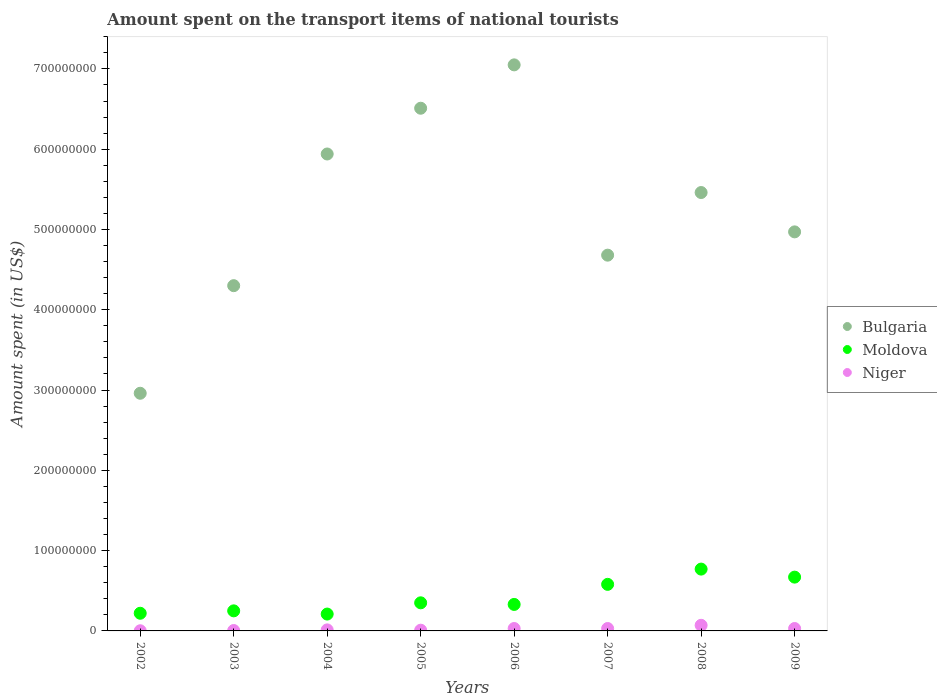Is the number of dotlines equal to the number of legend labels?
Provide a succinct answer. Yes. What is the amount spent on the transport items of national tourists in Bulgaria in 2007?
Keep it short and to the point. 4.68e+08. Across all years, what is the maximum amount spent on the transport items of national tourists in Bulgaria?
Provide a short and direct response. 7.05e+08. Across all years, what is the minimum amount spent on the transport items of national tourists in Bulgaria?
Give a very brief answer. 2.96e+08. What is the total amount spent on the transport items of national tourists in Moldova in the graph?
Give a very brief answer. 3.38e+08. What is the difference between the amount spent on the transport items of national tourists in Moldova in 2002 and that in 2003?
Keep it short and to the point. -3.00e+06. What is the difference between the amount spent on the transport items of national tourists in Moldova in 2004 and the amount spent on the transport items of national tourists in Niger in 2007?
Ensure brevity in your answer.  1.80e+07. What is the average amount spent on the transport items of national tourists in Niger per year?
Offer a very short reply. 2.36e+06. In the year 2005, what is the difference between the amount spent on the transport items of national tourists in Niger and amount spent on the transport items of national tourists in Moldova?
Ensure brevity in your answer.  -3.41e+07. Is the amount spent on the transport items of national tourists in Moldova in 2003 less than that in 2008?
Your answer should be compact. Yes. Is the difference between the amount spent on the transport items of national tourists in Niger in 2006 and 2009 greater than the difference between the amount spent on the transport items of national tourists in Moldova in 2006 and 2009?
Your response must be concise. Yes. What is the difference between the highest and the second highest amount spent on the transport items of national tourists in Niger?
Your answer should be compact. 4.00e+06. What is the difference between the highest and the lowest amount spent on the transport items of national tourists in Moldova?
Your answer should be compact. 5.60e+07. Is the sum of the amount spent on the transport items of national tourists in Bulgaria in 2006 and 2007 greater than the maximum amount spent on the transport items of national tourists in Moldova across all years?
Ensure brevity in your answer.  Yes. Is it the case that in every year, the sum of the amount spent on the transport items of national tourists in Bulgaria and amount spent on the transport items of national tourists in Niger  is greater than the amount spent on the transport items of national tourists in Moldova?
Your answer should be compact. Yes. Does the amount spent on the transport items of national tourists in Bulgaria monotonically increase over the years?
Provide a short and direct response. No. Is the amount spent on the transport items of national tourists in Moldova strictly greater than the amount spent on the transport items of national tourists in Niger over the years?
Make the answer very short. Yes. How many dotlines are there?
Ensure brevity in your answer.  3. Does the graph contain grids?
Offer a very short reply. No. What is the title of the graph?
Your answer should be very brief. Amount spent on the transport items of national tourists. What is the label or title of the Y-axis?
Offer a very short reply. Amount spent (in US$). What is the Amount spent (in US$) of Bulgaria in 2002?
Provide a short and direct response. 2.96e+08. What is the Amount spent (in US$) in Moldova in 2002?
Your response must be concise. 2.20e+07. What is the Amount spent (in US$) of Bulgaria in 2003?
Offer a very short reply. 4.30e+08. What is the Amount spent (in US$) of Moldova in 2003?
Make the answer very short. 2.50e+07. What is the Amount spent (in US$) in Niger in 2003?
Offer a very short reply. 5.00e+05. What is the Amount spent (in US$) of Bulgaria in 2004?
Ensure brevity in your answer.  5.94e+08. What is the Amount spent (in US$) in Moldova in 2004?
Make the answer very short. 2.10e+07. What is the Amount spent (in US$) of Niger in 2004?
Offer a very short reply. 1.30e+06. What is the Amount spent (in US$) in Bulgaria in 2005?
Offer a very short reply. 6.51e+08. What is the Amount spent (in US$) in Moldova in 2005?
Offer a terse response. 3.50e+07. What is the Amount spent (in US$) of Bulgaria in 2006?
Keep it short and to the point. 7.05e+08. What is the Amount spent (in US$) in Moldova in 2006?
Give a very brief answer. 3.30e+07. What is the Amount spent (in US$) of Bulgaria in 2007?
Offer a very short reply. 4.68e+08. What is the Amount spent (in US$) of Moldova in 2007?
Offer a very short reply. 5.80e+07. What is the Amount spent (in US$) of Niger in 2007?
Ensure brevity in your answer.  3.00e+06. What is the Amount spent (in US$) in Bulgaria in 2008?
Your response must be concise. 5.46e+08. What is the Amount spent (in US$) in Moldova in 2008?
Ensure brevity in your answer.  7.70e+07. What is the Amount spent (in US$) in Niger in 2008?
Your answer should be compact. 7.00e+06. What is the Amount spent (in US$) of Bulgaria in 2009?
Keep it short and to the point. 4.97e+08. What is the Amount spent (in US$) of Moldova in 2009?
Your answer should be compact. 6.70e+07. What is the Amount spent (in US$) in Niger in 2009?
Provide a short and direct response. 3.00e+06. Across all years, what is the maximum Amount spent (in US$) of Bulgaria?
Make the answer very short. 7.05e+08. Across all years, what is the maximum Amount spent (in US$) of Moldova?
Your answer should be very brief. 7.70e+07. Across all years, what is the minimum Amount spent (in US$) of Bulgaria?
Ensure brevity in your answer.  2.96e+08. Across all years, what is the minimum Amount spent (in US$) of Moldova?
Keep it short and to the point. 2.10e+07. Across all years, what is the minimum Amount spent (in US$) in Niger?
Offer a very short reply. 2.00e+05. What is the total Amount spent (in US$) in Bulgaria in the graph?
Offer a very short reply. 4.19e+09. What is the total Amount spent (in US$) in Moldova in the graph?
Provide a short and direct response. 3.38e+08. What is the total Amount spent (in US$) in Niger in the graph?
Provide a succinct answer. 1.89e+07. What is the difference between the Amount spent (in US$) of Bulgaria in 2002 and that in 2003?
Your answer should be very brief. -1.34e+08. What is the difference between the Amount spent (in US$) of Bulgaria in 2002 and that in 2004?
Provide a short and direct response. -2.98e+08. What is the difference between the Amount spent (in US$) of Moldova in 2002 and that in 2004?
Ensure brevity in your answer.  1.00e+06. What is the difference between the Amount spent (in US$) of Niger in 2002 and that in 2004?
Your answer should be compact. -1.10e+06. What is the difference between the Amount spent (in US$) of Bulgaria in 2002 and that in 2005?
Provide a succinct answer. -3.55e+08. What is the difference between the Amount spent (in US$) in Moldova in 2002 and that in 2005?
Provide a short and direct response. -1.30e+07. What is the difference between the Amount spent (in US$) in Niger in 2002 and that in 2005?
Provide a short and direct response. -7.00e+05. What is the difference between the Amount spent (in US$) of Bulgaria in 2002 and that in 2006?
Provide a succinct answer. -4.09e+08. What is the difference between the Amount spent (in US$) of Moldova in 2002 and that in 2006?
Make the answer very short. -1.10e+07. What is the difference between the Amount spent (in US$) of Niger in 2002 and that in 2006?
Offer a terse response. -2.80e+06. What is the difference between the Amount spent (in US$) of Bulgaria in 2002 and that in 2007?
Keep it short and to the point. -1.72e+08. What is the difference between the Amount spent (in US$) of Moldova in 2002 and that in 2007?
Your answer should be very brief. -3.60e+07. What is the difference between the Amount spent (in US$) in Niger in 2002 and that in 2007?
Your answer should be very brief. -2.80e+06. What is the difference between the Amount spent (in US$) in Bulgaria in 2002 and that in 2008?
Ensure brevity in your answer.  -2.50e+08. What is the difference between the Amount spent (in US$) in Moldova in 2002 and that in 2008?
Your response must be concise. -5.50e+07. What is the difference between the Amount spent (in US$) of Niger in 2002 and that in 2008?
Keep it short and to the point. -6.80e+06. What is the difference between the Amount spent (in US$) of Bulgaria in 2002 and that in 2009?
Your answer should be compact. -2.01e+08. What is the difference between the Amount spent (in US$) of Moldova in 2002 and that in 2009?
Offer a terse response. -4.50e+07. What is the difference between the Amount spent (in US$) in Niger in 2002 and that in 2009?
Your response must be concise. -2.80e+06. What is the difference between the Amount spent (in US$) in Bulgaria in 2003 and that in 2004?
Offer a very short reply. -1.64e+08. What is the difference between the Amount spent (in US$) of Niger in 2003 and that in 2004?
Make the answer very short. -8.00e+05. What is the difference between the Amount spent (in US$) of Bulgaria in 2003 and that in 2005?
Ensure brevity in your answer.  -2.21e+08. What is the difference between the Amount spent (in US$) in Moldova in 2003 and that in 2005?
Provide a succinct answer. -1.00e+07. What is the difference between the Amount spent (in US$) of Niger in 2003 and that in 2005?
Make the answer very short. -4.00e+05. What is the difference between the Amount spent (in US$) of Bulgaria in 2003 and that in 2006?
Offer a very short reply. -2.75e+08. What is the difference between the Amount spent (in US$) in Moldova in 2003 and that in 2006?
Keep it short and to the point. -8.00e+06. What is the difference between the Amount spent (in US$) in Niger in 2003 and that in 2006?
Give a very brief answer. -2.50e+06. What is the difference between the Amount spent (in US$) in Bulgaria in 2003 and that in 2007?
Keep it short and to the point. -3.80e+07. What is the difference between the Amount spent (in US$) in Moldova in 2003 and that in 2007?
Keep it short and to the point. -3.30e+07. What is the difference between the Amount spent (in US$) of Niger in 2003 and that in 2007?
Keep it short and to the point. -2.50e+06. What is the difference between the Amount spent (in US$) of Bulgaria in 2003 and that in 2008?
Offer a terse response. -1.16e+08. What is the difference between the Amount spent (in US$) in Moldova in 2003 and that in 2008?
Your response must be concise. -5.20e+07. What is the difference between the Amount spent (in US$) of Niger in 2003 and that in 2008?
Your response must be concise. -6.50e+06. What is the difference between the Amount spent (in US$) of Bulgaria in 2003 and that in 2009?
Offer a very short reply. -6.70e+07. What is the difference between the Amount spent (in US$) of Moldova in 2003 and that in 2009?
Give a very brief answer. -4.20e+07. What is the difference between the Amount spent (in US$) of Niger in 2003 and that in 2009?
Give a very brief answer. -2.50e+06. What is the difference between the Amount spent (in US$) in Bulgaria in 2004 and that in 2005?
Offer a very short reply. -5.70e+07. What is the difference between the Amount spent (in US$) in Moldova in 2004 and that in 2005?
Your answer should be compact. -1.40e+07. What is the difference between the Amount spent (in US$) of Bulgaria in 2004 and that in 2006?
Keep it short and to the point. -1.11e+08. What is the difference between the Amount spent (in US$) in Moldova in 2004 and that in 2006?
Ensure brevity in your answer.  -1.20e+07. What is the difference between the Amount spent (in US$) of Niger in 2004 and that in 2006?
Provide a succinct answer. -1.70e+06. What is the difference between the Amount spent (in US$) in Bulgaria in 2004 and that in 2007?
Provide a succinct answer. 1.26e+08. What is the difference between the Amount spent (in US$) in Moldova in 2004 and that in 2007?
Ensure brevity in your answer.  -3.70e+07. What is the difference between the Amount spent (in US$) of Niger in 2004 and that in 2007?
Your answer should be compact. -1.70e+06. What is the difference between the Amount spent (in US$) in Bulgaria in 2004 and that in 2008?
Make the answer very short. 4.80e+07. What is the difference between the Amount spent (in US$) in Moldova in 2004 and that in 2008?
Make the answer very short. -5.60e+07. What is the difference between the Amount spent (in US$) in Niger in 2004 and that in 2008?
Your answer should be very brief. -5.70e+06. What is the difference between the Amount spent (in US$) of Bulgaria in 2004 and that in 2009?
Keep it short and to the point. 9.70e+07. What is the difference between the Amount spent (in US$) in Moldova in 2004 and that in 2009?
Provide a succinct answer. -4.60e+07. What is the difference between the Amount spent (in US$) of Niger in 2004 and that in 2009?
Your answer should be very brief. -1.70e+06. What is the difference between the Amount spent (in US$) of Bulgaria in 2005 and that in 2006?
Provide a short and direct response. -5.40e+07. What is the difference between the Amount spent (in US$) in Niger in 2005 and that in 2006?
Offer a very short reply. -2.10e+06. What is the difference between the Amount spent (in US$) of Bulgaria in 2005 and that in 2007?
Provide a short and direct response. 1.83e+08. What is the difference between the Amount spent (in US$) in Moldova in 2005 and that in 2007?
Give a very brief answer. -2.30e+07. What is the difference between the Amount spent (in US$) in Niger in 2005 and that in 2007?
Ensure brevity in your answer.  -2.10e+06. What is the difference between the Amount spent (in US$) of Bulgaria in 2005 and that in 2008?
Ensure brevity in your answer.  1.05e+08. What is the difference between the Amount spent (in US$) of Moldova in 2005 and that in 2008?
Ensure brevity in your answer.  -4.20e+07. What is the difference between the Amount spent (in US$) of Niger in 2005 and that in 2008?
Your response must be concise. -6.10e+06. What is the difference between the Amount spent (in US$) in Bulgaria in 2005 and that in 2009?
Offer a terse response. 1.54e+08. What is the difference between the Amount spent (in US$) in Moldova in 2005 and that in 2009?
Offer a terse response. -3.20e+07. What is the difference between the Amount spent (in US$) in Niger in 2005 and that in 2009?
Your response must be concise. -2.10e+06. What is the difference between the Amount spent (in US$) of Bulgaria in 2006 and that in 2007?
Your answer should be very brief. 2.37e+08. What is the difference between the Amount spent (in US$) in Moldova in 2006 and that in 2007?
Keep it short and to the point. -2.50e+07. What is the difference between the Amount spent (in US$) of Bulgaria in 2006 and that in 2008?
Your response must be concise. 1.59e+08. What is the difference between the Amount spent (in US$) of Moldova in 2006 and that in 2008?
Offer a very short reply. -4.40e+07. What is the difference between the Amount spent (in US$) of Bulgaria in 2006 and that in 2009?
Keep it short and to the point. 2.08e+08. What is the difference between the Amount spent (in US$) in Moldova in 2006 and that in 2009?
Make the answer very short. -3.40e+07. What is the difference between the Amount spent (in US$) of Niger in 2006 and that in 2009?
Provide a succinct answer. 0. What is the difference between the Amount spent (in US$) in Bulgaria in 2007 and that in 2008?
Your answer should be compact. -7.80e+07. What is the difference between the Amount spent (in US$) in Moldova in 2007 and that in 2008?
Provide a short and direct response. -1.90e+07. What is the difference between the Amount spent (in US$) in Niger in 2007 and that in 2008?
Your answer should be compact. -4.00e+06. What is the difference between the Amount spent (in US$) of Bulgaria in 2007 and that in 2009?
Give a very brief answer. -2.90e+07. What is the difference between the Amount spent (in US$) in Moldova in 2007 and that in 2009?
Offer a terse response. -9.00e+06. What is the difference between the Amount spent (in US$) of Bulgaria in 2008 and that in 2009?
Your response must be concise. 4.90e+07. What is the difference between the Amount spent (in US$) in Bulgaria in 2002 and the Amount spent (in US$) in Moldova in 2003?
Offer a terse response. 2.71e+08. What is the difference between the Amount spent (in US$) in Bulgaria in 2002 and the Amount spent (in US$) in Niger in 2003?
Offer a terse response. 2.96e+08. What is the difference between the Amount spent (in US$) of Moldova in 2002 and the Amount spent (in US$) of Niger in 2003?
Your answer should be compact. 2.15e+07. What is the difference between the Amount spent (in US$) in Bulgaria in 2002 and the Amount spent (in US$) in Moldova in 2004?
Your response must be concise. 2.75e+08. What is the difference between the Amount spent (in US$) in Bulgaria in 2002 and the Amount spent (in US$) in Niger in 2004?
Offer a very short reply. 2.95e+08. What is the difference between the Amount spent (in US$) of Moldova in 2002 and the Amount spent (in US$) of Niger in 2004?
Give a very brief answer. 2.07e+07. What is the difference between the Amount spent (in US$) in Bulgaria in 2002 and the Amount spent (in US$) in Moldova in 2005?
Provide a succinct answer. 2.61e+08. What is the difference between the Amount spent (in US$) of Bulgaria in 2002 and the Amount spent (in US$) of Niger in 2005?
Offer a terse response. 2.95e+08. What is the difference between the Amount spent (in US$) in Moldova in 2002 and the Amount spent (in US$) in Niger in 2005?
Provide a short and direct response. 2.11e+07. What is the difference between the Amount spent (in US$) in Bulgaria in 2002 and the Amount spent (in US$) in Moldova in 2006?
Ensure brevity in your answer.  2.63e+08. What is the difference between the Amount spent (in US$) in Bulgaria in 2002 and the Amount spent (in US$) in Niger in 2006?
Keep it short and to the point. 2.93e+08. What is the difference between the Amount spent (in US$) in Moldova in 2002 and the Amount spent (in US$) in Niger in 2006?
Provide a succinct answer. 1.90e+07. What is the difference between the Amount spent (in US$) in Bulgaria in 2002 and the Amount spent (in US$) in Moldova in 2007?
Your response must be concise. 2.38e+08. What is the difference between the Amount spent (in US$) of Bulgaria in 2002 and the Amount spent (in US$) of Niger in 2007?
Offer a very short reply. 2.93e+08. What is the difference between the Amount spent (in US$) of Moldova in 2002 and the Amount spent (in US$) of Niger in 2007?
Provide a succinct answer. 1.90e+07. What is the difference between the Amount spent (in US$) in Bulgaria in 2002 and the Amount spent (in US$) in Moldova in 2008?
Provide a short and direct response. 2.19e+08. What is the difference between the Amount spent (in US$) of Bulgaria in 2002 and the Amount spent (in US$) of Niger in 2008?
Provide a succinct answer. 2.89e+08. What is the difference between the Amount spent (in US$) in Moldova in 2002 and the Amount spent (in US$) in Niger in 2008?
Your response must be concise. 1.50e+07. What is the difference between the Amount spent (in US$) of Bulgaria in 2002 and the Amount spent (in US$) of Moldova in 2009?
Give a very brief answer. 2.29e+08. What is the difference between the Amount spent (in US$) in Bulgaria in 2002 and the Amount spent (in US$) in Niger in 2009?
Your response must be concise. 2.93e+08. What is the difference between the Amount spent (in US$) of Moldova in 2002 and the Amount spent (in US$) of Niger in 2009?
Make the answer very short. 1.90e+07. What is the difference between the Amount spent (in US$) of Bulgaria in 2003 and the Amount spent (in US$) of Moldova in 2004?
Your answer should be very brief. 4.09e+08. What is the difference between the Amount spent (in US$) of Bulgaria in 2003 and the Amount spent (in US$) of Niger in 2004?
Provide a succinct answer. 4.29e+08. What is the difference between the Amount spent (in US$) in Moldova in 2003 and the Amount spent (in US$) in Niger in 2004?
Provide a succinct answer. 2.37e+07. What is the difference between the Amount spent (in US$) in Bulgaria in 2003 and the Amount spent (in US$) in Moldova in 2005?
Keep it short and to the point. 3.95e+08. What is the difference between the Amount spent (in US$) of Bulgaria in 2003 and the Amount spent (in US$) of Niger in 2005?
Ensure brevity in your answer.  4.29e+08. What is the difference between the Amount spent (in US$) of Moldova in 2003 and the Amount spent (in US$) of Niger in 2005?
Give a very brief answer. 2.41e+07. What is the difference between the Amount spent (in US$) in Bulgaria in 2003 and the Amount spent (in US$) in Moldova in 2006?
Make the answer very short. 3.97e+08. What is the difference between the Amount spent (in US$) in Bulgaria in 2003 and the Amount spent (in US$) in Niger in 2006?
Your answer should be compact. 4.27e+08. What is the difference between the Amount spent (in US$) of Moldova in 2003 and the Amount spent (in US$) of Niger in 2006?
Offer a terse response. 2.20e+07. What is the difference between the Amount spent (in US$) in Bulgaria in 2003 and the Amount spent (in US$) in Moldova in 2007?
Give a very brief answer. 3.72e+08. What is the difference between the Amount spent (in US$) in Bulgaria in 2003 and the Amount spent (in US$) in Niger in 2007?
Keep it short and to the point. 4.27e+08. What is the difference between the Amount spent (in US$) of Moldova in 2003 and the Amount spent (in US$) of Niger in 2007?
Your answer should be very brief. 2.20e+07. What is the difference between the Amount spent (in US$) in Bulgaria in 2003 and the Amount spent (in US$) in Moldova in 2008?
Give a very brief answer. 3.53e+08. What is the difference between the Amount spent (in US$) of Bulgaria in 2003 and the Amount spent (in US$) of Niger in 2008?
Keep it short and to the point. 4.23e+08. What is the difference between the Amount spent (in US$) in Moldova in 2003 and the Amount spent (in US$) in Niger in 2008?
Your answer should be compact. 1.80e+07. What is the difference between the Amount spent (in US$) of Bulgaria in 2003 and the Amount spent (in US$) of Moldova in 2009?
Ensure brevity in your answer.  3.63e+08. What is the difference between the Amount spent (in US$) of Bulgaria in 2003 and the Amount spent (in US$) of Niger in 2009?
Ensure brevity in your answer.  4.27e+08. What is the difference between the Amount spent (in US$) of Moldova in 2003 and the Amount spent (in US$) of Niger in 2009?
Provide a succinct answer. 2.20e+07. What is the difference between the Amount spent (in US$) in Bulgaria in 2004 and the Amount spent (in US$) in Moldova in 2005?
Keep it short and to the point. 5.59e+08. What is the difference between the Amount spent (in US$) in Bulgaria in 2004 and the Amount spent (in US$) in Niger in 2005?
Your answer should be compact. 5.93e+08. What is the difference between the Amount spent (in US$) of Moldova in 2004 and the Amount spent (in US$) of Niger in 2005?
Ensure brevity in your answer.  2.01e+07. What is the difference between the Amount spent (in US$) of Bulgaria in 2004 and the Amount spent (in US$) of Moldova in 2006?
Your answer should be very brief. 5.61e+08. What is the difference between the Amount spent (in US$) in Bulgaria in 2004 and the Amount spent (in US$) in Niger in 2006?
Your answer should be compact. 5.91e+08. What is the difference between the Amount spent (in US$) of Moldova in 2004 and the Amount spent (in US$) of Niger in 2006?
Ensure brevity in your answer.  1.80e+07. What is the difference between the Amount spent (in US$) of Bulgaria in 2004 and the Amount spent (in US$) of Moldova in 2007?
Your answer should be compact. 5.36e+08. What is the difference between the Amount spent (in US$) in Bulgaria in 2004 and the Amount spent (in US$) in Niger in 2007?
Give a very brief answer. 5.91e+08. What is the difference between the Amount spent (in US$) in Moldova in 2004 and the Amount spent (in US$) in Niger in 2007?
Keep it short and to the point. 1.80e+07. What is the difference between the Amount spent (in US$) in Bulgaria in 2004 and the Amount spent (in US$) in Moldova in 2008?
Make the answer very short. 5.17e+08. What is the difference between the Amount spent (in US$) of Bulgaria in 2004 and the Amount spent (in US$) of Niger in 2008?
Your response must be concise. 5.87e+08. What is the difference between the Amount spent (in US$) in Moldova in 2004 and the Amount spent (in US$) in Niger in 2008?
Give a very brief answer. 1.40e+07. What is the difference between the Amount spent (in US$) of Bulgaria in 2004 and the Amount spent (in US$) of Moldova in 2009?
Keep it short and to the point. 5.27e+08. What is the difference between the Amount spent (in US$) of Bulgaria in 2004 and the Amount spent (in US$) of Niger in 2009?
Your answer should be very brief. 5.91e+08. What is the difference between the Amount spent (in US$) in Moldova in 2004 and the Amount spent (in US$) in Niger in 2009?
Give a very brief answer. 1.80e+07. What is the difference between the Amount spent (in US$) of Bulgaria in 2005 and the Amount spent (in US$) of Moldova in 2006?
Ensure brevity in your answer.  6.18e+08. What is the difference between the Amount spent (in US$) of Bulgaria in 2005 and the Amount spent (in US$) of Niger in 2006?
Give a very brief answer. 6.48e+08. What is the difference between the Amount spent (in US$) of Moldova in 2005 and the Amount spent (in US$) of Niger in 2006?
Your response must be concise. 3.20e+07. What is the difference between the Amount spent (in US$) in Bulgaria in 2005 and the Amount spent (in US$) in Moldova in 2007?
Provide a succinct answer. 5.93e+08. What is the difference between the Amount spent (in US$) of Bulgaria in 2005 and the Amount spent (in US$) of Niger in 2007?
Your answer should be compact. 6.48e+08. What is the difference between the Amount spent (in US$) of Moldova in 2005 and the Amount spent (in US$) of Niger in 2007?
Provide a short and direct response. 3.20e+07. What is the difference between the Amount spent (in US$) of Bulgaria in 2005 and the Amount spent (in US$) of Moldova in 2008?
Give a very brief answer. 5.74e+08. What is the difference between the Amount spent (in US$) of Bulgaria in 2005 and the Amount spent (in US$) of Niger in 2008?
Keep it short and to the point. 6.44e+08. What is the difference between the Amount spent (in US$) of Moldova in 2005 and the Amount spent (in US$) of Niger in 2008?
Offer a very short reply. 2.80e+07. What is the difference between the Amount spent (in US$) of Bulgaria in 2005 and the Amount spent (in US$) of Moldova in 2009?
Your response must be concise. 5.84e+08. What is the difference between the Amount spent (in US$) in Bulgaria in 2005 and the Amount spent (in US$) in Niger in 2009?
Your answer should be very brief. 6.48e+08. What is the difference between the Amount spent (in US$) in Moldova in 2005 and the Amount spent (in US$) in Niger in 2009?
Your answer should be compact. 3.20e+07. What is the difference between the Amount spent (in US$) in Bulgaria in 2006 and the Amount spent (in US$) in Moldova in 2007?
Offer a terse response. 6.47e+08. What is the difference between the Amount spent (in US$) of Bulgaria in 2006 and the Amount spent (in US$) of Niger in 2007?
Your answer should be very brief. 7.02e+08. What is the difference between the Amount spent (in US$) in Moldova in 2006 and the Amount spent (in US$) in Niger in 2007?
Make the answer very short. 3.00e+07. What is the difference between the Amount spent (in US$) of Bulgaria in 2006 and the Amount spent (in US$) of Moldova in 2008?
Offer a very short reply. 6.28e+08. What is the difference between the Amount spent (in US$) of Bulgaria in 2006 and the Amount spent (in US$) of Niger in 2008?
Give a very brief answer. 6.98e+08. What is the difference between the Amount spent (in US$) in Moldova in 2006 and the Amount spent (in US$) in Niger in 2008?
Offer a very short reply. 2.60e+07. What is the difference between the Amount spent (in US$) of Bulgaria in 2006 and the Amount spent (in US$) of Moldova in 2009?
Provide a short and direct response. 6.38e+08. What is the difference between the Amount spent (in US$) of Bulgaria in 2006 and the Amount spent (in US$) of Niger in 2009?
Your answer should be compact. 7.02e+08. What is the difference between the Amount spent (in US$) of Moldova in 2006 and the Amount spent (in US$) of Niger in 2009?
Ensure brevity in your answer.  3.00e+07. What is the difference between the Amount spent (in US$) of Bulgaria in 2007 and the Amount spent (in US$) of Moldova in 2008?
Give a very brief answer. 3.91e+08. What is the difference between the Amount spent (in US$) of Bulgaria in 2007 and the Amount spent (in US$) of Niger in 2008?
Offer a very short reply. 4.61e+08. What is the difference between the Amount spent (in US$) in Moldova in 2007 and the Amount spent (in US$) in Niger in 2008?
Provide a succinct answer. 5.10e+07. What is the difference between the Amount spent (in US$) in Bulgaria in 2007 and the Amount spent (in US$) in Moldova in 2009?
Your response must be concise. 4.01e+08. What is the difference between the Amount spent (in US$) in Bulgaria in 2007 and the Amount spent (in US$) in Niger in 2009?
Your answer should be very brief. 4.65e+08. What is the difference between the Amount spent (in US$) in Moldova in 2007 and the Amount spent (in US$) in Niger in 2009?
Ensure brevity in your answer.  5.50e+07. What is the difference between the Amount spent (in US$) in Bulgaria in 2008 and the Amount spent (in US$) in Moldova in 2009?
Your answer should be very brief. 4.79e+08. What is the difference between the Amount spent (in US$) in Bulgaria in 2008 and the Amount spent (in US$) in Niger in 2009?
Offer a terse response. 5.43e+08. What is the difference between the Amount spent (in US$) of Moldova in 2008 and the Amount spent (in US$) of Niger in 2009?
Provide a succinct answer. 7.40e+07. What is the average Amount spent (in US$) of Bulgaria per year?
Your answer should be very brief. 5.23e+08. What is the average Amount spent (in US$) in Moldova per year?
Keep it short and to the point. 4.22e+07. What is the average Amount spent (in US$) of Niger per year?
Your answer should be compact. 2.36e+06. In the year 2002, what is the difference between the Amount spent (in US$) in Bulgaria and Amount spent (in US$) in Moldova?
Give a very brief answer. 2.74e+08. In the year 2002, what is the difference between the Amount spent (in US$) of Bulgaria and Amount spent (in US$) of Niger?
Offer a terse response. 2.96e+08. In the year 2002, what is the difference between the Amount spent (in US$) of Moldova and Amount spent (in US$) of Niger?
Your answer should be very brief. 2.18e+07. In the year 2003, what is the difference between the Amount spent (in US$) of Bulgaria and Amount spent (in US$) of Moldova?
Provide a succinct answer. 4.05e+08. In the year 2003, what is the difference between the Amount spent (in US$) of Bulgaria and Amount spent (in US$) of Niger?
Ensure brevity in your answer.  4.30e+08. In the year 2003, what is the difference between the Amount spent (in US$) of Moldova and Amount spent (in US$) of Niger?
Give a very brief answer. 2.45e+07. In the year 2004, what is the difference between the Amount spent (in US$) in Bulgaria and Amount spent (in US$) in Moldova?
Offer a terse response. 5.73e+08. In the year 2004, what is the difference between the Amount spent (in US$) of Bulgaria and Amount spent (in US$) of Niger?
Your answer should be compact. 5.93e+08. In the year 2004, what is the difference between the Amount spent (in US$) of Moldova and Amount spent (in US$) of Niger?
Make the answer very short. 1.97e+07. In the year 2005, what is the difference between the Amount spent (in US$) of Bulgaria and Amount spent (in US$) of Moldova?
Offer a very short reply. 6.16e+08. In the year 2005, what is the difference between the Amount spent (in US$) of Bulgaria and Amount spent (in US$) of Niger?
Ensure brevity in your answer.  6.50e+08. In the year 2005, what is the difference between the Amount spent (in US$) in Moldova and Amount spent (in US$) in Niger?
Give a very brief answer. 3.41e+07. In the year 2006, what is the difference between the Amount spent (in US$) of Bulgaria and Amount spent (in US$) of Moldova?
Offer a very short reply. 6.72e+08. In the year 2006, what is the difference between the Amount spent (in US$) of Bulgaria and Amount spent (in US$) of Niger?
Your answer should be very brief. 7.02e+08. In the year 2006, what is the difference between the Amount spent (in US$) of Moldova and Amount spent (in US$) of Niger?
Offer a terse response. 3.00e+07. In the year 2007, what is the difference between the Amount spent (in US$) of Bulgaria and Amount spent (in US$) of Moldova?
Offer a very short reply. 4.10e+08. In the year 2007, what is the difference between the Amount spent (in US$) in Bulgaria and Amount spent (in US$) in Niger?
Make the answer very short. 4.65e+08. In the year 2007, what is the difference between the Amount spent (in US$) in Moldova and Amount spent (in US$) in Niger?
Provide a succinct answer. 5.50e+07. In the year 2008, what is the difference between the Amount spent (in US$) in Bulgaria and Amount spent (in US$) in Moldova?
Offer a very short reply. 4.69e+08. In the year 2008, what is the difference between the Amount spent (in US$) in Bulgaria and Amount spent (in US$) in Niger?
Provide a succinct answer. 5.39e+08. In the year 2008, what is the difference between the Amount spent (in US$) of Moldova and Amount spent (in US$) of Niger?
Give a very brief answer. 7.00e+07. In the year 2009, what is the difference between the Amount spent (in US$) in Bulgaria and Amount spent (in US$) in Moldova?
Offer a terse response. 4.30e+08. In the year 2009, what is the difference between the Amount spent (in US$) of Bulgaria and Amount spent (in US$) of Niger?
Ensure brevity in your answer.  4.94e+08. In the year 2009, what is the difference between the Amount spent (in US$) of Moldova and Amount spent (in US$) of Niger?
Your answer should be very brief. 6.40e+07. What is the ratio of the Amount spent (in US$) in Bulgaria in 2002 to that in 2003?
Offer a terse response. 0.69. What is the ratio of the Amount spent (in US$) in Niger in 2002 to that in 2003?
Make the answer very short. 0.4. What is the ratio of the Amount spent (in US$) in Bulgaria in 2002 to that in 2004?
Offer a terse response. 0.5. What is the ratio of the Amount spent (in US$) in Moldova in 2002 to that in 2004?
Your response must be concise. 1.05. What is the ratio of the Amount spent (in US$) in Niger in 2002 to that in 2004?
Offer a terse response. 0.15. What is the ratio of the Amount spent (in US$) of Bulgaria in 2002 to that in 2005?
Keep it short and to the point. 0.45. What is the ratio of the Amount spent (in US$) of Moldova in 2002 to that in 2005?
Your answer should be compact. 0.63. What is the ratio of the Amount spent (in US$) of Niger in 2002 to that in 2005?
Provide a short and direct response. 0.22. What is the ratio of the Amount spent (in US$) in Bulgaria in 2002 to that in 2006?
Your response must be concise. 0.42. What is the ratio of the Amount spent (in US$) in Niger in 2002 to that in 2006?
Offer a terse response. 0.07. What is the ratio of the Amount spent (in US$) in Bulgaria in 2002 to that in 2007?
Keep it short and to the point. 0.63. What is the ratio of the Amount spent (in US$) in Moldova in 2002 to that in 2007?
Offer a terse response. 0.38. What is the ratio of the Amount spent (in US$) of Niger in 2002 to that in 2007?
Your answer should be very brief. 0.07. What is the ratio of the Amount spent (in US$) in Bulgaria in 2002 to that in 2008?
Ensure brevity in your answer.  0.54. What is the ratio of the Amount spent (in US$) in Moldova in 2002 to that in 2008?
Your answer should be compact. 0.29. What is the ratio of the Amount spent (in US$) in Niger in 2002 to that in 2008?
Offer a terse response. 0.03. What is the ratio of the Amount spent (in US$) of Bulgaria in 2002 to that in 2009?
Provide a succinct answer. 0.6. What is the ratio of the Amount spent (in US$) of Moldova in 2002 to that in 2009?
Offer a terse response. 0.33. What is the ratio of the Amount spent (in US$) of Niger in 2002 to that in 2009?
Give a very brief answer. 0.07. What is the ratio of the Amount spent (in US$) in Bulgaria in 2003 to that in 2004?
Offer a very short reply. 0.72. What is the ratio of the Amount spent (in US$) in Moldova in 2003 to that in 2004?
Your answer should be compact. 1.19. What is the ratio of the Amount spent (in US$) of Niger in 2003 to that in 2004?
Your answer should be compact. 0.38. What is the ratio of the Amount spent (in US$) of Bulgaria in 2003 to that in 2005?
Make the answer very short. 0.66. What is the ratio of the Amount spent (in US$) in Niger in 2003 to that in 2005?
Give a very brief answer. 0.56. What is the ratio of the Amount spent (in US$) of Bulgaria in 2003 to that in 2006?
Provide a short and direct response. 0.61. What is the ratio of the Amount spent (in US$) of Moldova in 2003 to that in 2006?
Ensure brevity in your answer.  0.76. What is the ratio of the Amount spent (in US$) of Bulgaria in 2003 to that in 2007?
Keep it short and to the point. 0.92. What is the ratio of the Amount spent (in US$) in Moldova in 2003 to that in 2007?
Make the answer very short. 0.43. What is the ratio of the Amount spent (in US$) of Bulgaria in 2003 to that in 2008?
Make the answer very short. 0.79. What is the ratio of the Amount spent (in US$) of Moldova in 2003 to that in 2008?
Keep it short and to the point. 0.32. What is the ratio of the Amount spent (in US$) in Niger in 2003 to that in 2008?
Provide a short and direct response. 0.07. What is the ratio of the Amount spent (in US$) in Bulgaria in 2003 to that in 2009?
Your answer should be very brief. 0.87. What is the ratio of the Amount spent (in US$) of Moldova in 2003 to that in 2009?
Ensure brevity in your answer.  0.37. What is the ratio of the Amount spent (in US$) of Bulgaria in 2004 to that in 2005?
Your answer should be compact. 0.91. What is the ratio of the Amount spent (in US$) in Moldova in 2004 to that in 2005?
Keep it short and to the point. 0.6. What is the ratio of the Amount spent (in US$) of Niger in 2004 to that in 2005?
Offer a terse response. 1.44. What is the ratio of the Amount spent (in US$) in Bulgaria in 2004 to that in 2006?
Your response must be concise. 0.84. What is the ratio of the Amount spent (in US$) in Moldova in 2004 to that in 2006?
Give a very brief answer. 0.64. What is the ratio of the Amount spent (in US$) of Niger in 2004 to that in 2006?
Your answer should be compact. 0.43. What is the ratio of the Amount spent (in US$) of Bulgaria in 2004 to that in 2007?
Keep it short and to the point. 1.27. What is the ratio of the Amount spent (in US$) of Moldova in 2004 to that in 2007?
Offer a very short reply. 0.36. What is the ratio of the Amount spent (in US$) of Niger in 2004 to that in 2007?
Provide a short and direct response. 0.43. What is the ratio of the Amount spent (in US$) of Bulgaria in 2004 to that in 2008?
Your answer should be compact. 1.09. What is the ratio of the Amount spent (in US$) in Moldova in 2004 to that in 2008?
Keep it short and to the point. 0.27. What is the ratio of the Amount spent (in US$) of Niger in 2004 to that in 2008?
Your answer should be compact. 0.19. What is the ratio of the Amount spent (in US$) in Bulgaria in 2004 to that in 2009?
Provide a short and direct response. 1.2. What is the ratio of the Amount spent (in US$) in Moldova in 2004 to that in 2009?
Provide a succinct answer. 0.31. What is the ratio of the Amount spent (in US$) in Niger in 2004 to that in 2009?
Offer a terse response. 0.43. What is the ratio of the Amount spent (in US$) of Bulgaria in 2005 to that in 2006?
Offer a very short reply. 0.92. What is the ratio of the Amount spent (in US$) in Moldova in 2005 to that in 2006?
Your answer should be very brief. 1.06. What is the ratio of the Amount spent (in US$) of Bulgaria in 2005 to that in 2007?
Keep it short and to the point. 1.39. What is the ratio of the Amount spent (in US$) in Moldova in 2005 to that in 2007?
Your response must be concise. 0.6. What is the ratio of the Amount spent (in US$) in Bulgaria in 2005 to that in 2008?
Your response must be concise. 1.19. What is the ratio of the Amount spent (in US$) in Moldova in 2005 to that in 2008?
Provide a succinct answer. 0.45. What is the ratio of the Amount spent (in US$) in Niger in 2005 to that in 2008?
Make the answer very short. 0.13. What is the ratio of the Amount spent (in US$) of Bulgaria in 2005 to that in 2009?
Offer a terse response. 1.31. What is the ratio of the Amount spent (in US$) of Moldova in 2005 to that in 2009?
Offer a terse response. 0.52. What is the ratio of the Amount spent (in US$) of Niger in 2005 to that in 2009?
Provide a succinct answer. 0.3. What is the ratio of the Amount spent (in US$) of Bulgaria in 2006 to that in 2007?
Keep it short and to the point. 1.51. What is the ratio of the Amount spent (in US$) in Moldova in 2006 to that in 2007?
Provide a short and direct response. 0.57. What is the ratio of the Amount spent (in US$) of Niger in 2006 to that in 2007?
Offer a terse response. 1. What is the ratio of the Amount spent (in US$) of Bulgaria in 2006 to that in 2008?
Keep it short and to the point. 1.29. What is the ratio of the Amount spent (in US$) in Moldova in 2006 to that in 2008?
Keep it short and to the point. 0.43. What is the ratio of the Amount spent (in US$) in Niger in 2006 to that in 2008?
Provide a succinct answer. 0.43. What is the ratio of the Amount spent (in US$) of Bulgaria in 2006 to that in 2009?
Keep it short and to the point. 1.42. What is the ratio of the Amount spent (in US$) of Moldova in 2006 to that in 2009?
Provide a succinct answer. 0.49. What is the ratio of the Amount spent (in US$) in Moldova in 2007 to that in 2008?
Your answer should be very brief. 0.75. What is the ratio of the Amount spent (in US$) of Niger in 2007 to that in 2008?
Your response must be concise. 0.43. What is the ratio of the Amount spent (in US$) of Bulgaria in 2007 to that in 2009?
Offer a very short reply. 0.94. What is the ratio of the Amount spent (in US$) of Moldova in 2007 to that in 2009?
Your answer should be compact. 0.87. What is the ratio of the Amount spent (in US$) in Niger in 2007 to that in 2009?
Provide a succinct answer. 1. What is the ratio of the Amount spent (in US$) of Bulgaria in 2008 to that in 2009?
Your answer should be very brief. 1.1. What is the ratio of the Amount spent (in US$) of Moldova in 2008 to that in 2009?
Your response must be concise. 1.15. What is the ratio of the Amount spent (in US$) of Niger in 2008 to that in 2009?
Keep it short and to the point. 2.33. What is the difference between the highest and the second highest Amount spent (in US$) of Bulgaria?
Keep it short and to the point. 5.40e+07. What is the difference between the highest and the lowest Amount spent (in US$) of Bulgaria?
Provide a short and direct response. 4.09e+08. What is the difference between the highest and the lowest Amount spent (in US$) in Moldova?
Offer a very short reply. 5.60e+07. What is the difference between the highest and the lowest Amount spent (in US$) in Niger?
Your answer should be compact. 6.80e+06. 